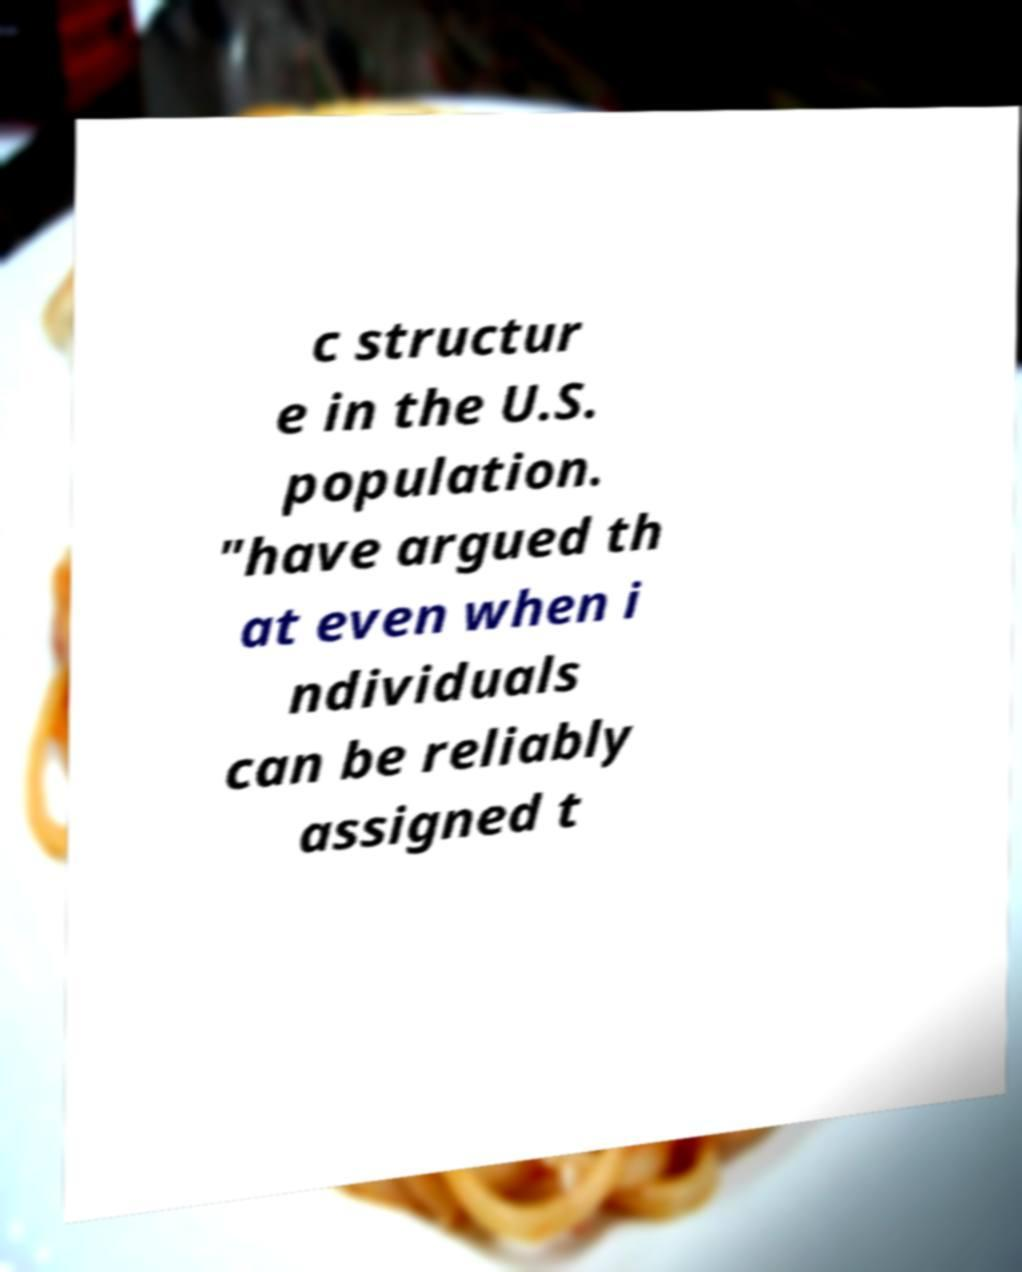For documentation purposes, I need the text within this image transcribed. Could you provide that? c structur e in the U.S. population. "have argued th at even when i ndividuals can be reliably assigned t 